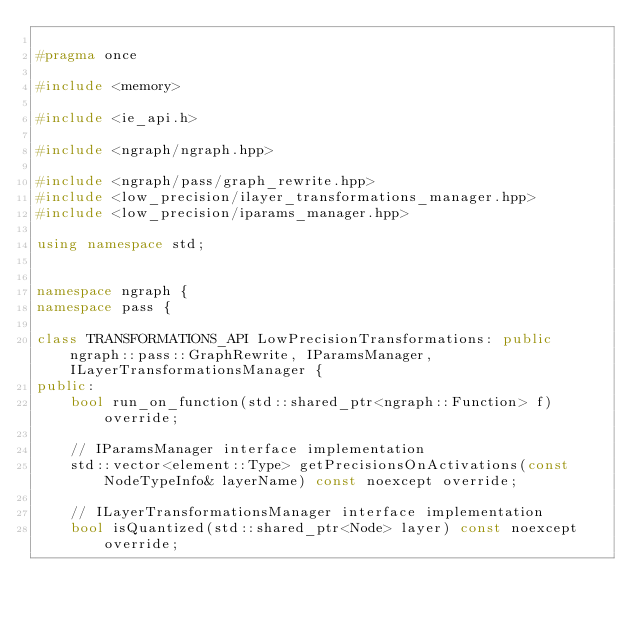<code> <loc_0><loc_0><loc_500><loc_500><_C++_>
#pragma once

#include <memory>

#include <ie_api.h>

#include <ngraph/ngraph.hpp>

#include <ngraph/pass/graph_rewrite.hpp>
#include <low_precision/ilayer_transformations_manager.hpp>
#include <low_precision/iparams_manager.hpp>

using namespace std;


namespace ngraph {
namespace pass {

class TRANSFORMATIONS_API LowPrecisionTransformations: public ngraph::pass::GraphRewrite, IParamsManager, ILayerTransformationsManager {
public:
    bool run_on_function(std::shared_ptr<ngraph::Function> f) override;

    // IParamsManager interface implementation
    std::vector<element::Type> getPrecisionsOnActivations(const NodeTypeInfo& layerName) const noexcept override;

    // ILayerTransformationsManager interface implementation
    bool isQuantized(std::shared_ptr<Node> layer) const noexcept override;</code> 